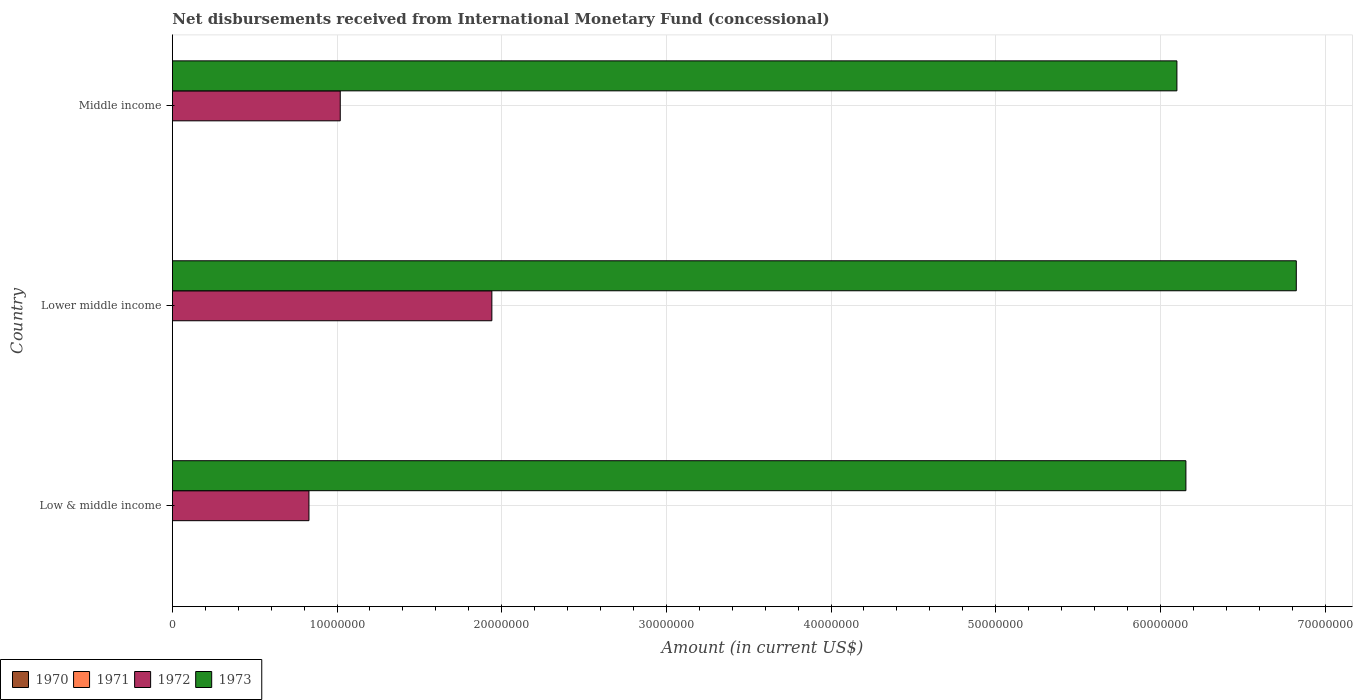How many groups of bars are there?
Provide a succinct answer. 3. Are the number of bars on each tick of the Y-axis equal?
Your answer should be very brief. Yes. How many bars are there on the 1st tick from the top?
Offer a terse response. 2. What is the label of the 2nd group of bars from the top?
Give a very brief answer. Lower middle income. What is the amount of disbursements received from International Monetary Fund in 1972 in Lower middle income?
Ensure brevity in your answer.  1.94e+07. Across all countries, what is the maximum amount of disbursements received from International Monetary Fund in 1972?
Ensure brevity in your answer.  1.94e+07. Across all countries, what is the minimum amount of disbursements received from International Monetary Fund in 1970?
Offer a terse response. 0. In which country was the amount of disbursements received from International Monetary Fund in 1972 maximum?
Your answer should be compact. Lower middle income. What is the total amount of disbursements received from International Monetary Fund in 1972 in the graph?
Provide a succinct answer. 3.79e+07. What is the difference between the amount of disbursements received from International Monetary Fund in 1972 in Lower middle income and that in Middle income?
Your answer should be compact. 9.21e+06. What is the difference between the amount of disbursements received from International Monetary Fund in 1973 in Lower middle income and the amount of disbursements received from International Monetary Fund in 1971 in Low & middle income?
Your answer should be compact. 6.83e+07. What is the average amount of disbursements received from International Monetary Fund in 1972 per country?
Offer a very short reply. 1.26e+07. What is the difference between the amount of disbursements received from International Monetary Fund in 1972 and amount of disbursements received from International Monetary Fund in 1973 in Low & middle income?
Your response must be concise. -5.33e+07. What is the ratio of the amount of disbursements received from International Monetary Fund in 1973 in Low & middle income to that in Middle income?
Your response must be concise. 1.01. What is the difference between the highest and the second highest amount of disbursements received from International Monetary Fund in 1973?
Keep it short and to the point. 6.70e+06. What is the difference between the highest and the lowest amount of disbursements received from International Monetary Fund in 1973?
Your response must be concise. 7.25e+06. Is it the case that in every country, the sum of the amount of disbursements received from International Monetary Fund in 1972 and amount of disbursements received from International Monetary Fund in 1970 is greater than the sum of amount of disbursements received from International Monetary Fund in 1971 and amount of disbursements received from International Monetary Fund in 1973?
Offer a very short reply. No. Is it the case that in every country, the sum of the amount of disbursements received from International Monetary Fund in 1970 and amount of disbursements received from International Monetary Fund in 1972 is greater than the amount of disbursements received from International Monetary Fund in 1973?
Offer a very short reply. No. Does the graph contain grids?
Offer a terse response. Yes. Where does the legend appear in the graph?
Your answer should be compact. Bottom left. How many legend labels are there?
Ensure brevity in your answer.  4. What is the title of the graph?
Your response must be concise. Net disbursements received from International Monetary Fund (concessional). Does "1983" appear as one of the legend labels in the graph?
Offer a terse response. No. What is the label or title of the X-axis?
Provide a succinct answer. Amount (in current US$). What is the label or title of the Y-axis?
Offer a terse response. Country. What is the Amount (in current US$) of 1971 in Low & middle income?
Your answer should be very brief. 0. What is the Amount (in current US$) of 1972 in Low & middle income?
Offer a very short reply. 8.30e+06. What is the Amount (in current US$) of 1973 in Low & middle income?
Give a very brief answer. 6.16e+07. What is the Amount (in current US$) in 1971 in Lower middle income?
Offer a terse response. 0. What is the Amount (in current US$) in 1972 in Lower middle income?
Offer a very short reply. 1.94e+07. What is the Amount (in current US$) of 1973 in Lower middle income?
Keep it short and to the point. 6.83e+07. What is the Amount (in current US$) in 1971 in Middle income?
Provide a short and direct response. 0. What is the Amount (in current US$) in 1972 in Middle income?
Provide a short and direct response. 1.02e+07. What is the Amount (in current US$) of 1973 in Middle income?
Your answer should be very brief. 6.10e+07. Across all countries, what is the maximum Amount (in current US$) of 1972?
Make the answer very short. 1.94e+07. Across all countries, what is the maximum Amount (in current US$) in 1973?
Your response must be concise. 6.83e+07. Across all countries, what is the minimum Amount (in current US$) of 1972?
Ensure brevity in your answer.  8.30e+06. Across all countries, what is the minimum Amount (in current US$) in 1973?
Provide a short and direct response. 6.10e+07. What is the total Amount (in current US$) in 1972 in the graph?
Ensure brevity in your answer.  3.79e+07. What is the total Amount (in current US$) in 1973 in the graph?
Keep it short and to the point. 1.91e+08. What is the difference between the Amount (in current US$) in 1972 in Low & middle income and that in Lower middle income?
Make the answer very short. -1.11e+07. What is the difference between the Amount (in current US$) in 1973 in Low & middle income and that in Lower middle income?
Your answer should be very brief. -6.70e+06. What is the difference between the Amount (in current US$) in 1972 in Low & middle income and that in Middle income?
Ensure brevity in your answer.  -1.90e+06. What is the difference between the Amount (in current US$) in 1973 in Low & middle income and that in Middle income?
Your answer should be very brief. 5.46e+05. What is the difference between the Amount (in current US$) in 1972 in Lower middle income and that in Middle income?
Provide a short and direct response. 9.21e+06. What is the difference between the Amount (in current US$) of 1973 in Lower middle income and that in Middle income?
Keep it short and to the point. 7.25e+06. What is the difference between the Amount (in current US$) in 1972 in Low & middle income and the Amount (in current US$) in 1973 in Lower middle income?
Make the answer very short. -6.00e+07. What is the difference between the Amount (in current US$) of 1972 in Low & middle income and the Amount (in current US$) of 1973 in Middle income?
Offer a very short reply. -5.27e+07. What is the difference between the Amount (in current US$) in 1972 in Lower middle income and the Amount (in current US$) in 1973 in Middle income?
Your answer should be compact. -4.16e+07. What is the average Amount (in current US$) of 1970 per country?
Provide a succinct answer. 0. What is the average Amount (in current US$) of 1971 per country?
Keep it short and to the point. 0. What is the average Amount (in current US$) of 1972 per country?
Your answer should be very brief. 1.26e+07. What is the average Amount (in current US$) in 1973 per country?
Make the answer very short. 6.36e+07. What is the difference between the Amount (in current US$) of 1972 and Amount (in current US$) of 1973 in Low & middle income?
Provide a short and direct response. -5.33e+07. What is the difference between the Amount (in current US$) of 1972 and Amount (in current US$) of 1973 in Lower middle income?
Provide a succinct answer. -4.89e+07. What is the difference between the Amount (in current US$) in 1972 and Amount (in current US$) in 1973 in Middle income?
Your answer should be compact. -5.08e+07. What is the ratio of the Amount (in current US$) in 1972 in Low & middle income to that in Lower middle income?
Provide a succinct answer. 0.43. What is the ratio of the Amount (in current US$) in 1973 in Low & middle income to that in Lower middle income?
Offer a terse response. 0.9. What is the ratio of the Amount (in current US$) of 1972 in Low & middle income to that in Middle income?
Provide a succinct answer. 0.81. What is the ratio of the Amount (in current US$) of 1972 in Lower middle income to that in Middle income?
Your answer should be very brief. 1.9. What is the ratio of the Amount (in current US$) in 1973 in Lower middle income to that in Middle income?
Provide a short and direct response. 1.12. What is the difference between the highest and the second highest Amount (in current US$) in 1972?
Make the answer very short. 9.21e+06. What is the difference between the highest and the second highest Amount (in current US$) of 1973?
Your answer should be very brief. 6.70e+06. What is the difference between the highest and the lowest Amount (in current US$) of 1972?
Offer a very short reply. 1.11e+07. What is the difference between the highest and the lowest Amount (in current US$) of 1973?
Offer a terse response. 7.25e+06. 